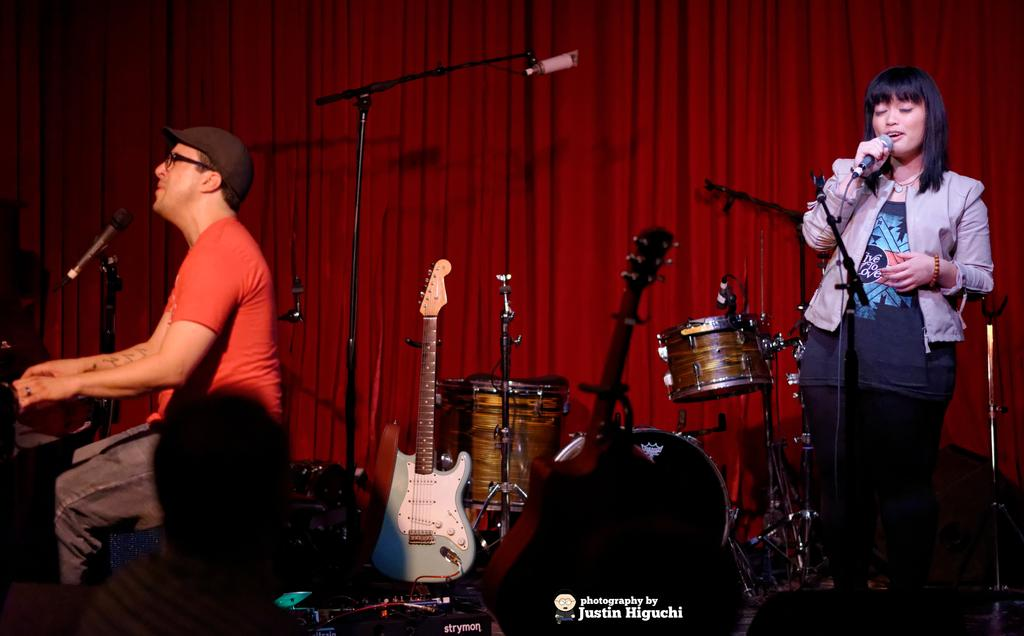What is the man in the image doing? The man is playing a musical instrument. What is the woman in the image doing? The woman is singing on a microphone. What else can be seen in the image besides the people? There are musical instruments visible in the image. What type of background element is present in the image? There is a curtain in the image. What year is depicted in the image? The image does not depict a specific year; it is a timeless scene of people playing music and singing. Can you tell me how many cups are visible in the image? There are no cups present in the image. 